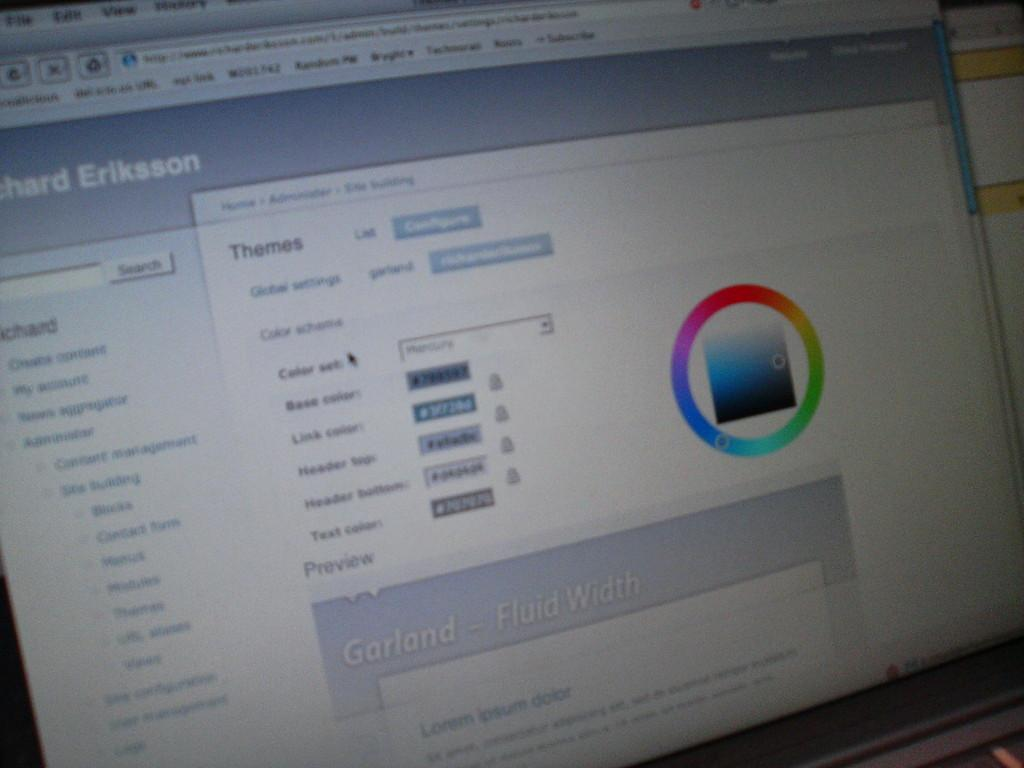What is the main object in the image? There is a monitor screen in the image. What can be seen on the monitor screen? There is text or content visible on the monitor screen. Can you describe the colors present in the image? There are colors present in the image. What type of hat is being sold in the shop shown in the image? There is no shop or hat present in the image; it only features a monitor screen with text or content and colors. 